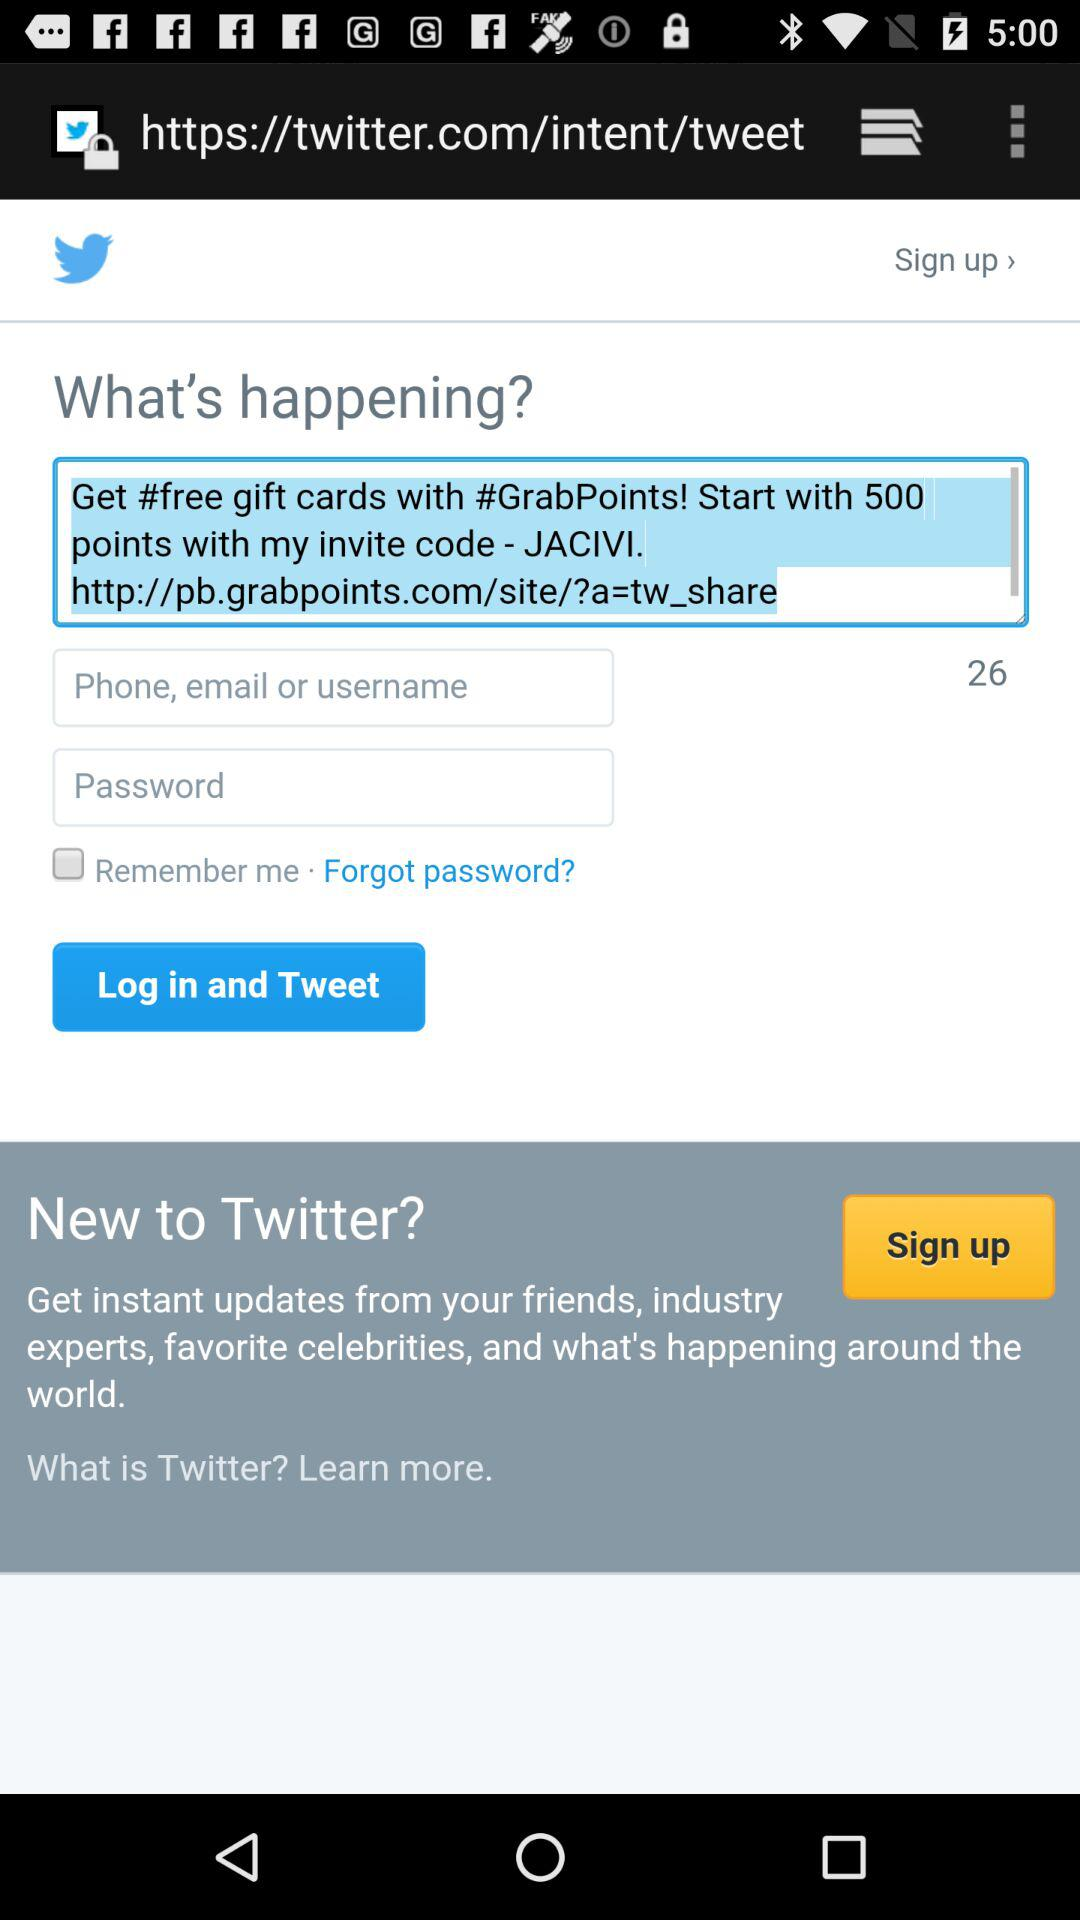What is the status of "Remember me"? The status of "Remember me" is "off". 